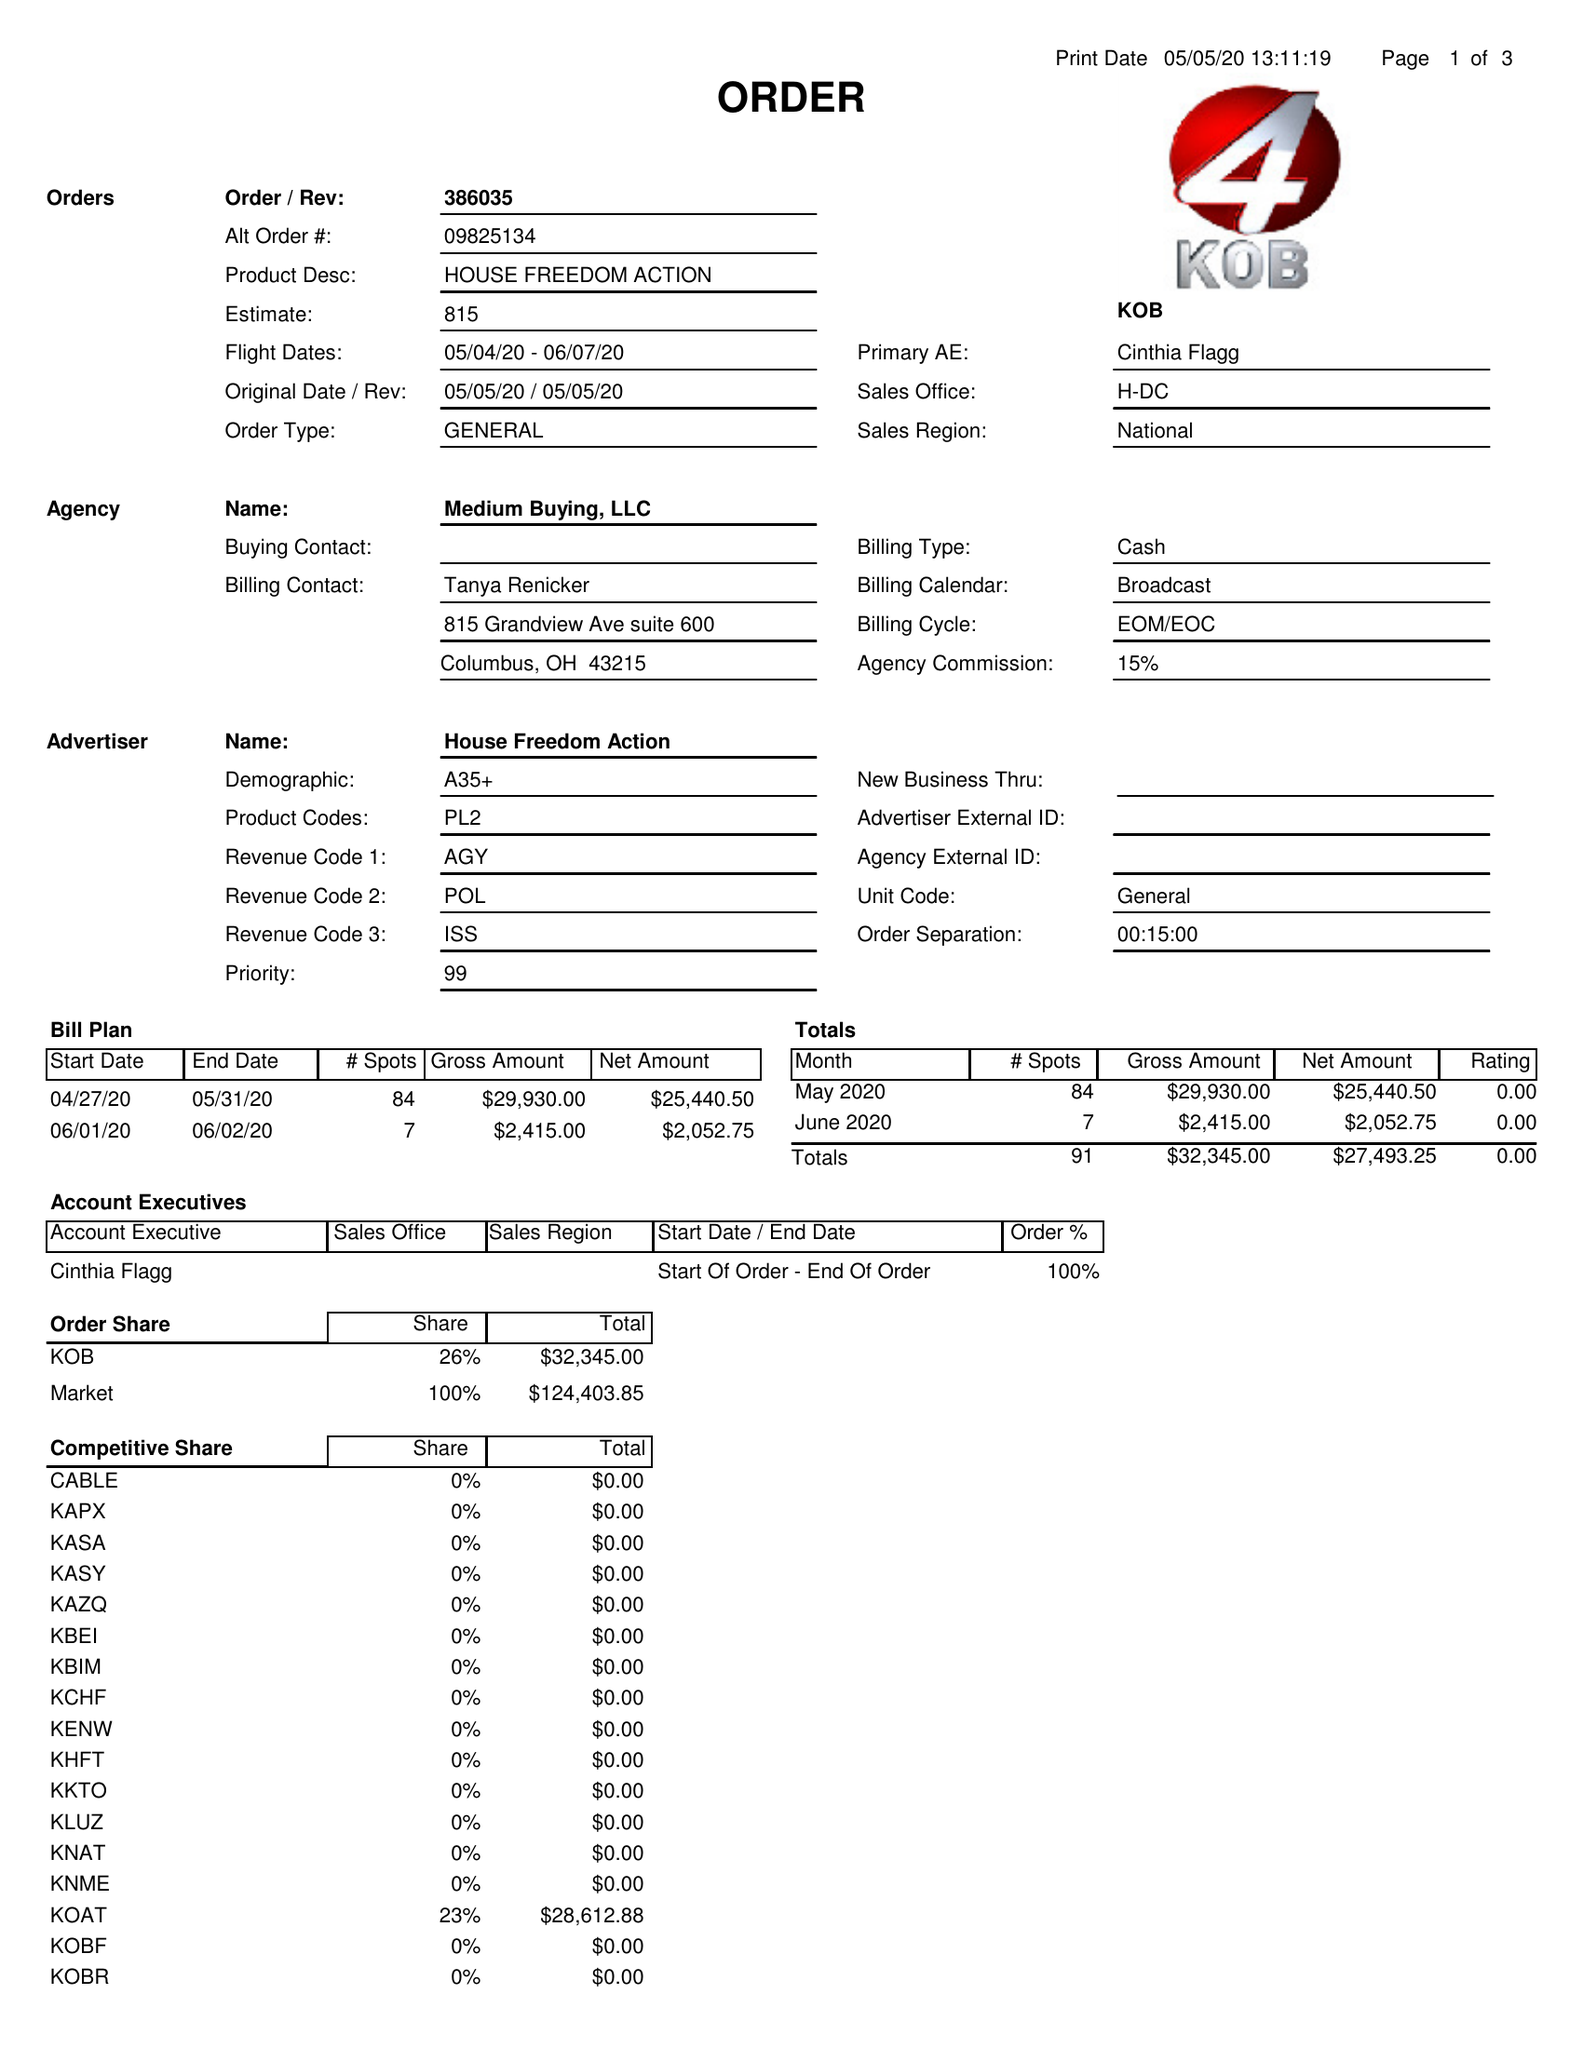What is the value for the flight_to?
Answer the question using a single word or phrase. 06/07/20 